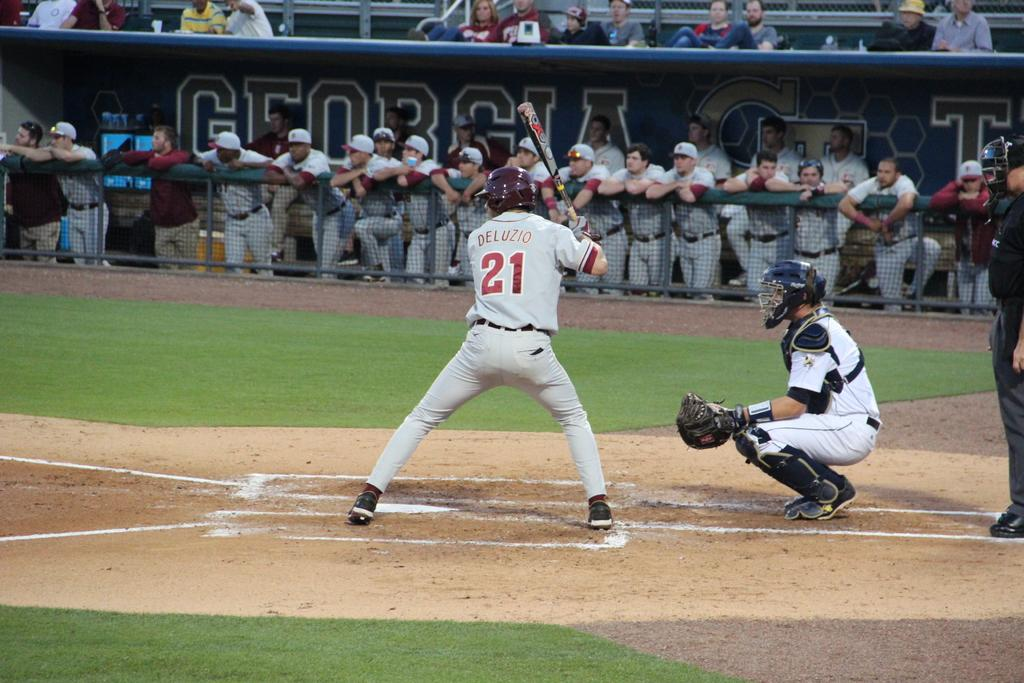<image>
Offer a succinct explanation of the picture presented. Baseball player wearing a number 21 on it. 